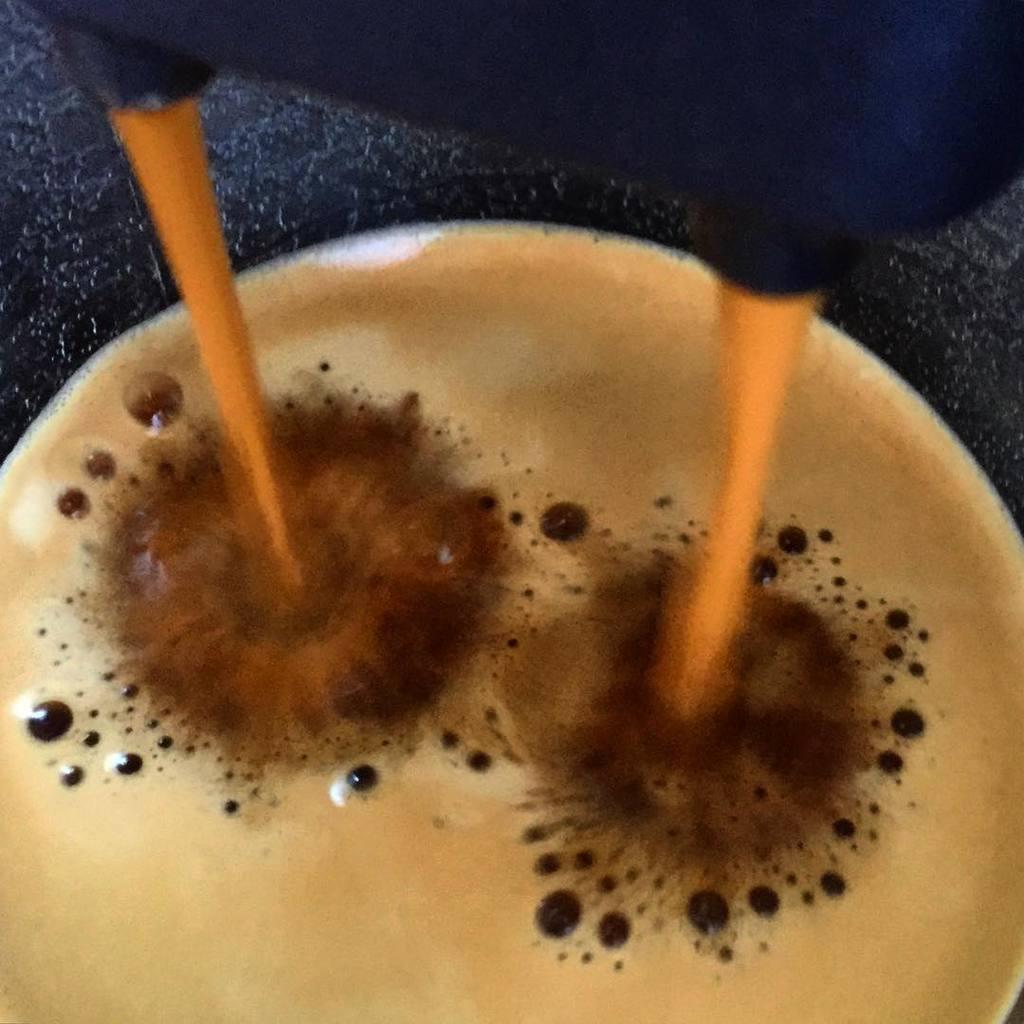Describe this image in one or two sentences. In the center of the image there is a coffee machine and a coffee cup. 